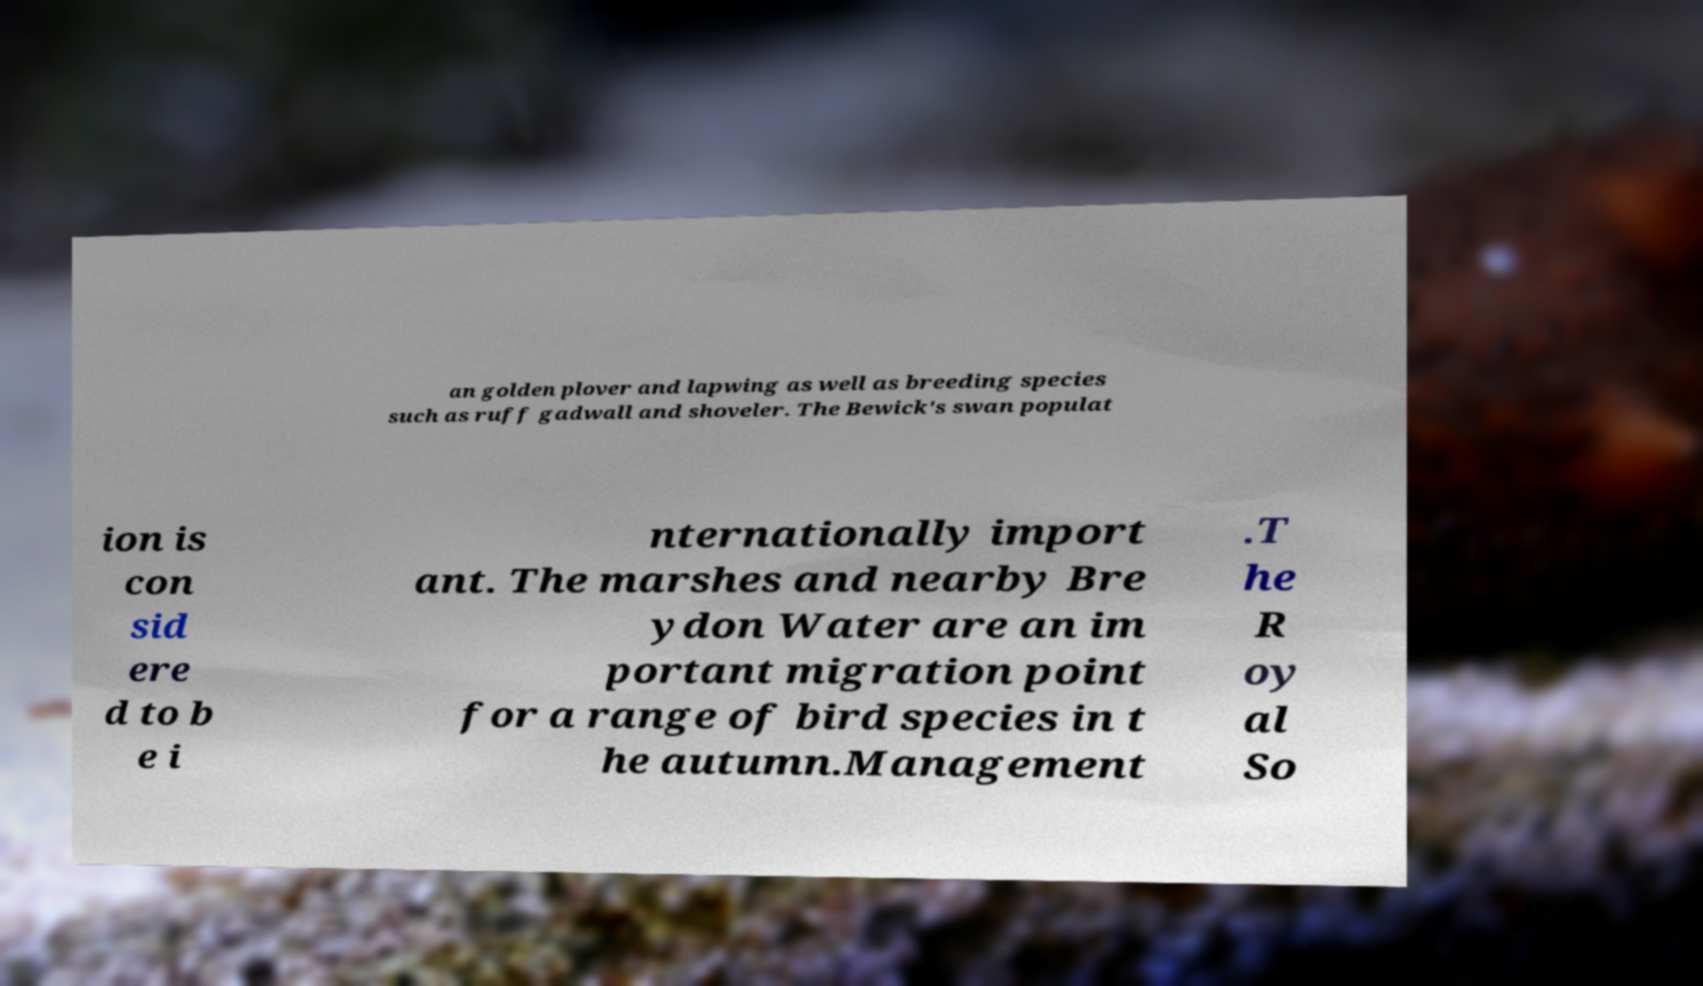Could you assist in decoding the text presented in this image and type it out clearly? an golden plover and lapwing as well as breeding species such as ruff gadwall and shoveler. The Bewick's swan populat ion is con sid ere d to b e i nternationally import ant. The marshes and nearby Bre ydon Water are an im portant migration point for a range of bird species in t he autumn.Management .T he R oy al So 